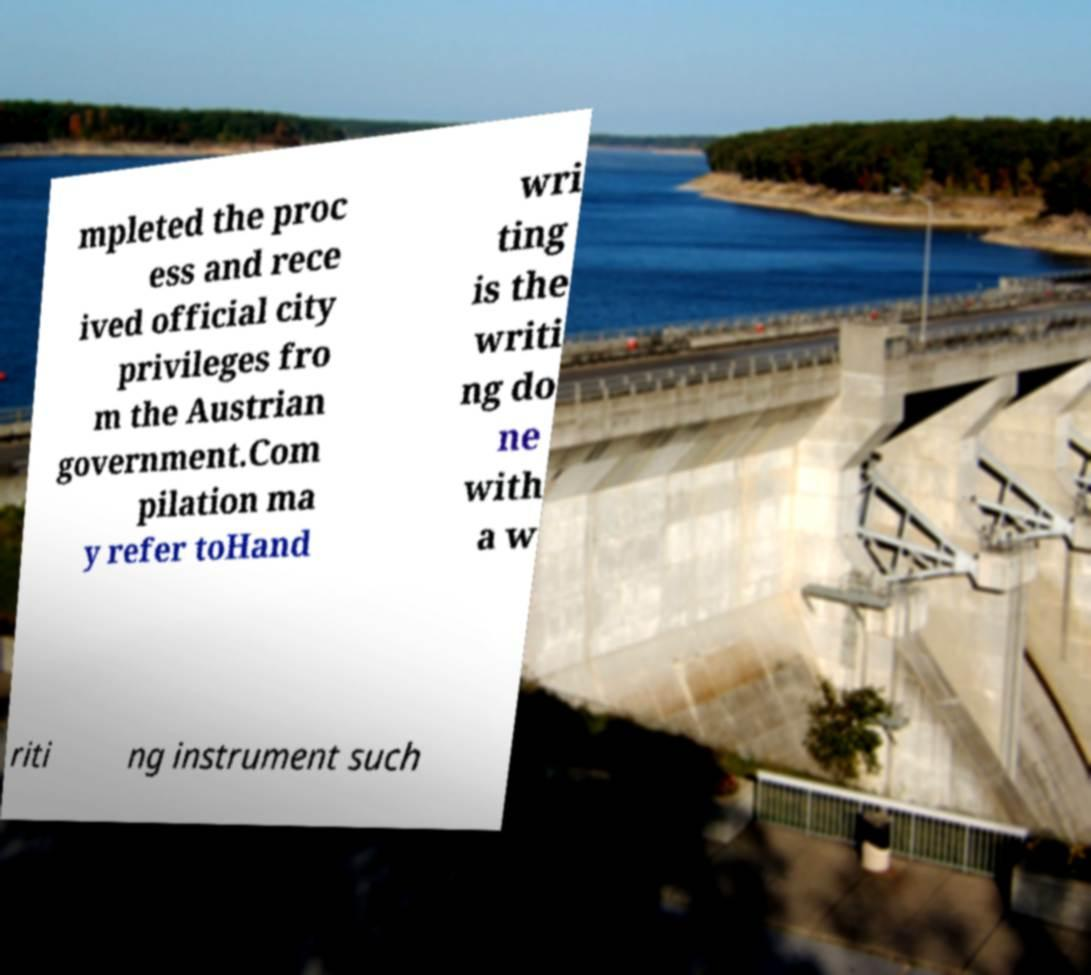Could you assist in decoding the text presented in this image and type it out clearly? mpleted the proc ess and rece ived official city privileges fro m the Austrian government.Com pilation ma y refer toHand wri ting is the writi ng do ne with a w riti ng instrument such 